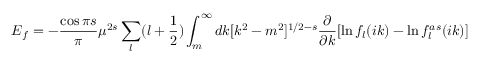Convert formula to latex. <formula><loc_0><loc_0><loc_500><loc_500>E _ { f } = - { \frac { \cos { \pi s } } { \pi } } \mu ^ { 2 s } \sum _ { l } ( l + \frac { 1 } { 2 } ) \int _ { m } ^ { \infty } d k [ k ^ { 2 } - m ^ { 2 } ] ^ { 1 / 2 - s } \frac { \partial } { \partial k } [ \ln f _ { l } ( i k ) - \ln f _ { l } ^ { a s } ( i k ) ]</formula> 